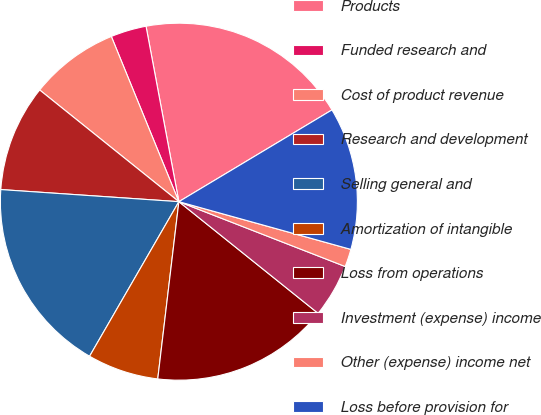Convert chart to OTSL. <chart><loc_0><loc_0><loc_500><loc_500><pie_chart><fcel>Products<fcel>Funded research and<fcel>Cost of product revenue<fcel>Research and development<fcel>Selling general and<fcel>Amortization of intangible<fcel>Loss from operations<fcel>Investment (expense) income<fcel>Other (expense) income net<fcel>Loss before provision for<nl><fcel>19.35%<fcel>3.23%<fcel>8.06%<fcel>9.68%<fcel>17.74%<fcel>6.45%<fcel>16.13%<fcel>4.84%<fcel>1.61%<fcel>12.9%<nl></chart> 